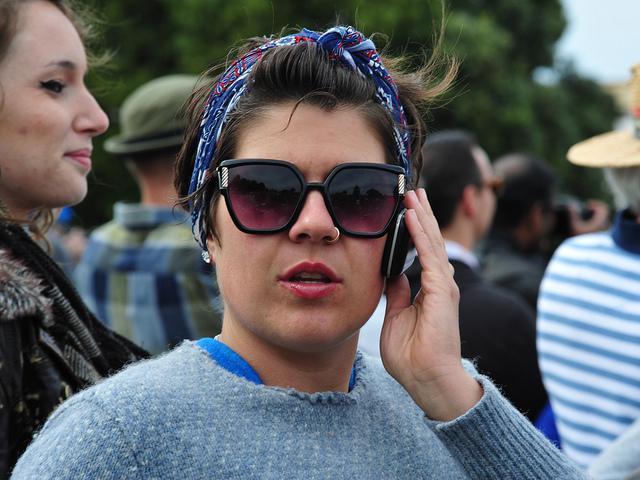How many people can be seen?
Give a very brief answer. 6. How many dominos pizza logos do you see?
Give a very brief answer. 0. 